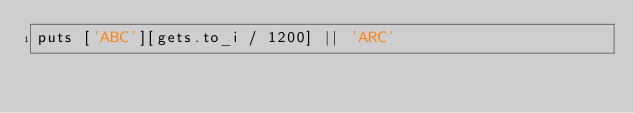<code> <loc_0><loc_0><loc_500><loc_500><_Ruby_>puts ['ABC'][gets.to_i / 1200] || 'ARC'</code> 